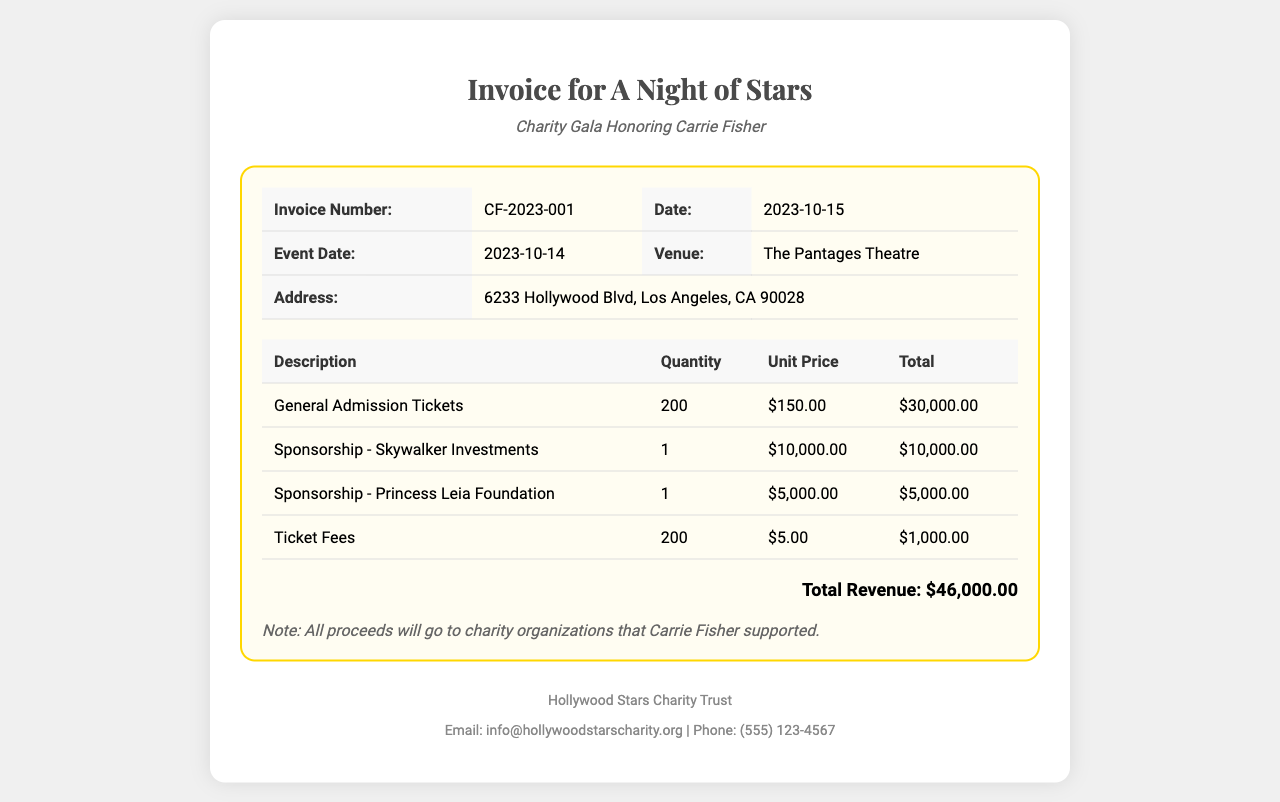What is the invoice number? The invoice number is displayed in the document, specifically under "Invoice Number", and is CF-2023-001.
Answer: CF-2023-001 What is the date of the event? The date of the event is mentioned in the "Event Date" section of the document, which is 2023-10-14.
Answer: 2023-10-14 How many general admission tickets were sold? The document states the quantity of general admission tickets sold under "Description" as 200.
Answer: 200 What is the total revenue? The total revenue is calculated and represented at the bottom of the invoice as $46,000.00.
Answer: $46,000.00 Which venue hosted the charity gala? The venue for the event is listed in the "Venue" section as The Pantages Theatre.
Answer: The Pantages Theatre How much was paid for ticket fees? The ticket fees are detailed in the invoice as $1,000.00, calculated for 200 tickets at $5.00 each.
Answer: $1,000.00 Who are the sponsors listed in the invoice? The sponsors are mentioned in the "Description" table as Skywalker Investments and Princess Leia Foundation.
Answer: Skywalker Investments; Princess Leia Foundation What is the email address for Hollywood Stars Charity Trust? The email address is provided in the footer of the document as info@hollywoodstarscharity.org.
Answer: info@hollywoodstarscharity.org What note is included about the proceeds? The note at the bottom informs that all proceeds will go to charity organizations supported by Carrie Fisher.
Answer: All proceeds will go to charity organizations that Carrie Fisher supported 